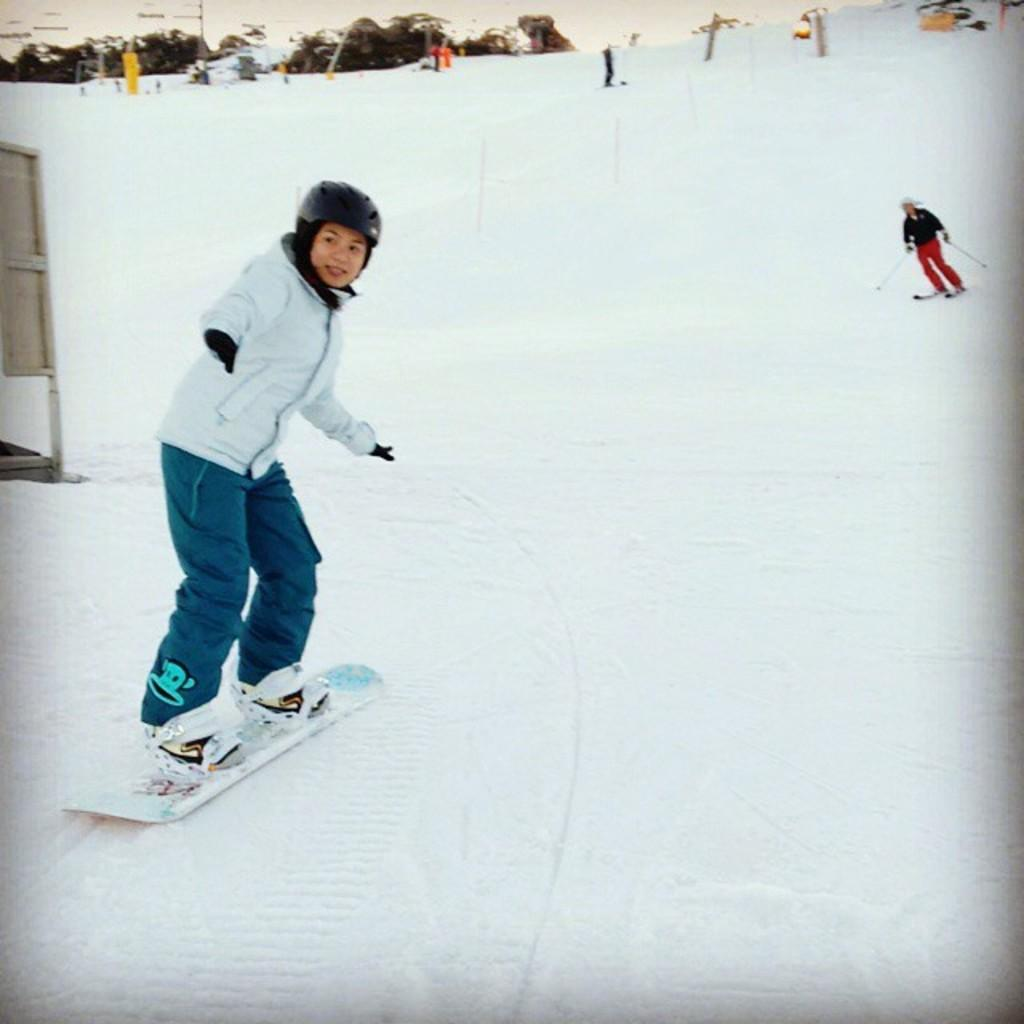What activity are the people in the image engaged in? The people in the image are skiing. What type of terrain is visible in the image? There is snow in the image, which suggests a winter or mountainous setting. What natural elements can be seen in the image? There are trees in the image. What structures are present in the image? There are poles and a stand in the image. What type of birds can be seen flying over the skiing area in the image? There are no birds visible in the image; it only shows people skiing, snow, trees, poles, and a stand. 